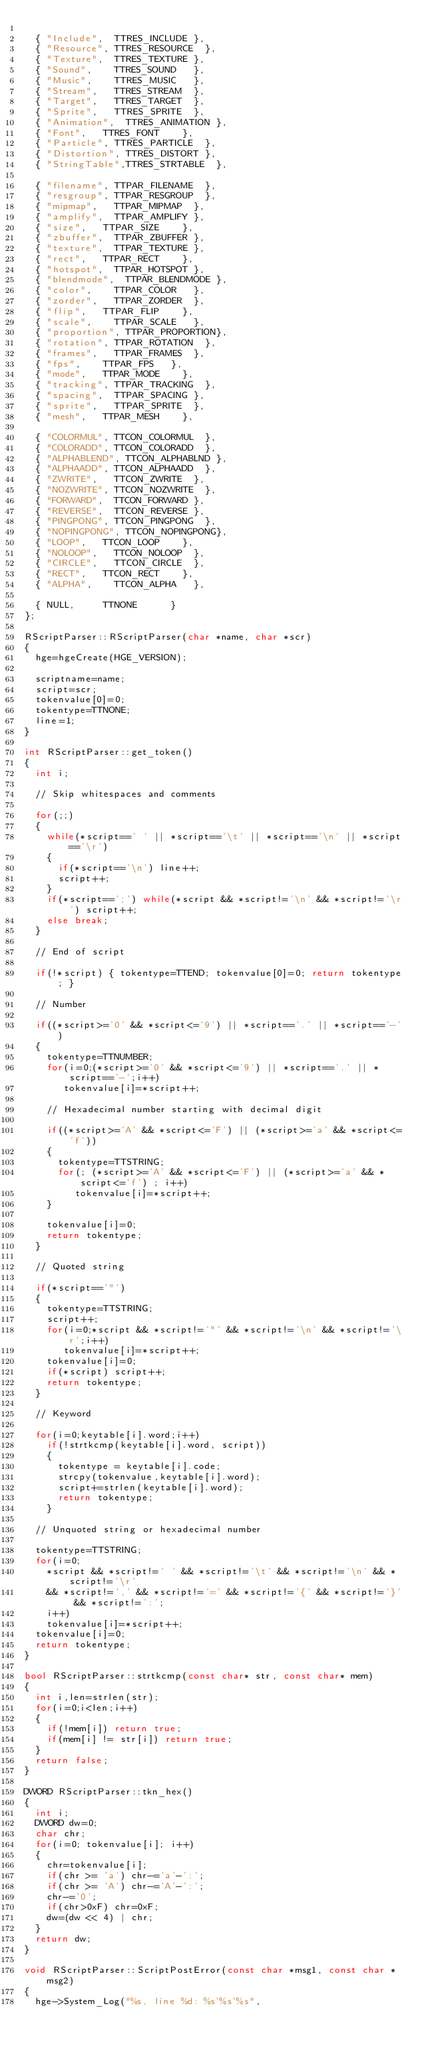<code> <loc_0><loc_0><loc_500><loc_500><_C++_>
	{ "Include",	TTRES_INCLUDE	},
	{ "Resource",	TTRES_RESOURCE	},
	{ "Texture",	TTRES_TEXTURE	},
	{ "Sound",		TTRES_SOUND		},
	{ "Music",		TTRES_MUSIC		},
	{ "Stream",		TTRES_STREAM	},
	{ "Target",		TTRES_TARGET	},
	{ "Sprite",		TTRES_SPRITE	},
	{ "Animation",	TTRES_ANIMATION	},
	{ "Font",		TTRES_FONT		},
	{ "Particle",	TTRES_PARTICLE	},
	{ "Distortion",	TTRES_DISTORT	},
	{ "StringTable",TTRES_STRTABLE	},

	{ "filename",	TTPAR_FILENAME	},
	{ "resgroup",	TTPAR_RESGROUP	},
	{ "mipmap",		TTPAR_MIPMAP	},
	{ "amplify",	TTPAR_AMPLIFY	},
	{ "size",		TTPAR_SIZE		},
	{ "zbuffer",	TTPAR_ZBUFFER	},
	{ "texture",	TTPAR_TEXTURE	},
	{ "rect",		TTPAR_RECT		},
	{ "hotspot",	TTPAR_HOTSPOT	},
	{ "blendmode",	TTPAR_BLENDMODE	},
	{ "color",		TTPAR_COLOR		},
	{ "zorder",		TTPAR_ZORDER	},
	{ "flip",		TTPAR_FLIP		},
	{ "scale",		TTPAR_SCALE		},
	{ "proportion",	TTPAR_PROPORTION},
	{ "rotation",	TTPAR_ROTATION	},
	{ "frames",		TTPAR_FRAMES	},
	{ "fps",		TTPAR_FPS		},
	{ "mode",		TTPAR_MODE		},
	{ "tracking",	TTPAR_TRACKING	},
	{ "spacing",	TTPAR_SPACING	},
	{ "sprite",		TTPAR_SPRITE	},
	{ "mesh",		TTPAR_MESH		},

	{ "COLORMUL",	TTCON_COLORMUL	},
	{ "COLORADD",	TTCON_COLORADD	},
	{ "ALPHABLEND",	TTCON_ALPHABLND	},
	{ "ALPHAADD",	TTCON_ALPHAADD	},
	{ "ZWRITE",		TTCON_ZWRITE	},
	{ "NOZWRITE",	TTCON_NOZWRITE	},
	{ "FORWARD",	TTCON_FORWARD	},
	{ "REVERSE",	TTCON_REVERSE	},
	{ "PINGPONG",	TTCON_PINGPONG	},
	{ "NOPINGPONG",	TTCON_NOPINGPONG},
	{ "LOOP",		TTCON_LOOP		},
	{ "NOLOOP",		TTCON_NOLOOP	},
	{ "CIRCLE",		TTCON_CIRCLE	},
	{ "RECT",		TTCON_RECT		},
	{ "ALPHA",		TTCON_ALPHA		},

	{ NULL,			TTNONE			}
};

RScriptParser::RScriptParser(char *name, char *scr)
{
	hge=hgeCreate(HGE_VERSION);

	scriptname=name;
	script=scr;
	tokenvalue[0]=0;
	tokentype=TTNONE;
	line=1;
}

int RScriptParser::get_token()
{
	int i;

	// Skip whitespaces and comments

	for(;;)
	{
		while(*script==' ' || *script=='\t' || *script=='\n' || *script=='\r')
		{
			if(*script=='\n') line++;
			script++;
		}
		if(*script==';') while(*script && *script!='\n' && *script!='\r') script++;
		else break;
	}

	// End of script

	if(!*script) { tokentype=TTEND; tokenvalue[0]=0; return tokentype; }

	// Number

	if((*script>='0' && *script<='9') || *script=='.' || *script=='-')
	{
		tokentype=TTNUMBER;
		for(i=0;(*script>='0' && *script<='9') || *script=='.' || *script=='-';i++)
			 tokenvalue[i]=*script++;

		// Hexadecimal number starting with decimal digit

		if((*script>='A' && *script<='F') || (*script>='a' && *script<='f'))
		{
			tokentype=TTSTRING;
			for(; (*script>='A' && *script<='F') || (*script>='a' && *script<='f') ; i++)
				 tokenvalue[i]=*script++;
		}

		tokenvalue[i]=0;
		return tokentype;
	}

	// Quoted string

	if(*script=='"')
	{
		tokentype=TTSTRING;
		script++;
		for(i=0;*script && *script!='"' && *script!='\n' && *script!='\r';i++)
			 tokenvalue[i]=*script++;
		tokenvalue[i]=0;
		if(*script) script++;
		return tokentype;
	}

	// Keyword

	for(i=0;keytable[i].word;i++)
		if(!strtkcmp(keytable[i].word, script))
		{
			tokentype = keytable[i].code;
			strcpy(tokenvalue,keytable[i].word);
			script+=strlen(keytable[i].word);
			return tokentype;
		}

	// Unquoted string or hexadecimal number

	tokentype=TTSTRING;
	for(i=0;
		*script && *script!=' ' && *script!='\t' && *script!='\n' && *script!='\r'
		&& *script!=',' && *script!='=' && *script!='{' && *script!='}' && *script!=':';
		i++)
		tokenvalue[i]=*script++;
	tokenvalue[i]=0;
	return tokentype;
}

bool RScriptParser::strtkcmp(const char* str, const char* mem)
{
	int i,len=strlen(str);
	for(i=0;i<len;i++)
	{
		if(!mem[i]) return true;
		if(mem[i] != str[i]) return true;
	}
	return false;
}

DWORD RScriptParser::tkn_hex()
{
	int i;
	DWORD dw=0;
	char chr;
	for(i=0; tokenvalue[i]; i++)
	{
		chr=tokenvalue[i];
		if(chr >= 'a') chr-='a'-':';
		if(chr >= 'A') chr-='A'-':';
		chr-='0';
		if(chr>0xF) chr=0xF;
		dw=(dw << 4) | chr;
	}
	return dw;
}

void RScriptParser::ScriptPostError(const char *msg1, const char *msg2)
{
	hge->System_Log("%s, line %d: %s'%s'%s",</code> 